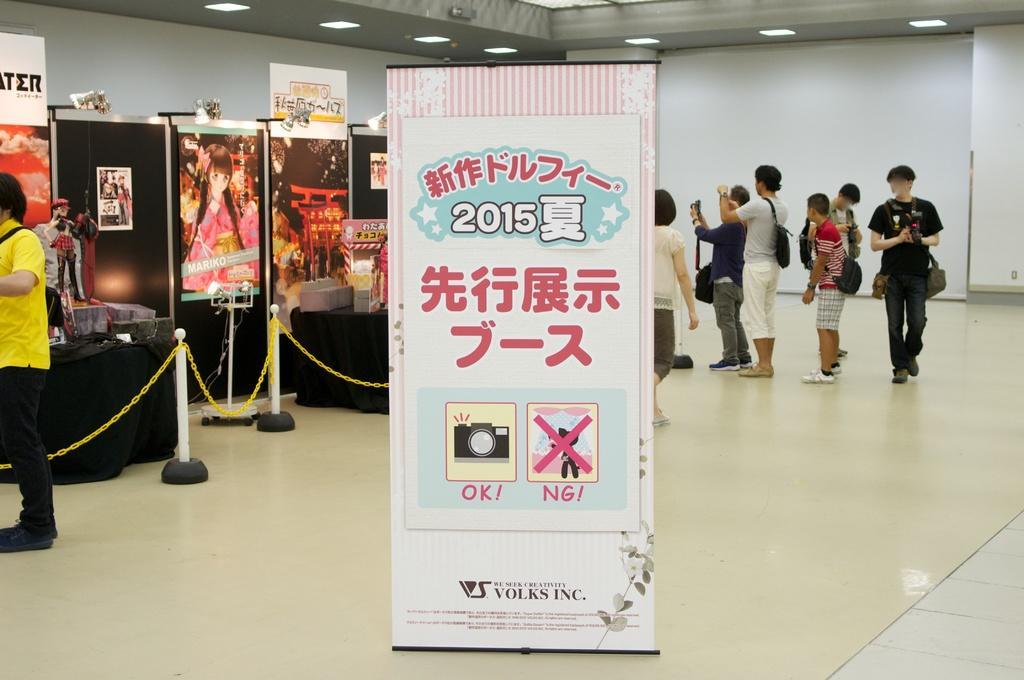How would you summarize this image in a sentence or two? In the image we can see there are many people standing and some of them are walking, they are wearing clothes, shoes and some of them are carrying bags. Here we can see the banners and text on it. Here we can see police, lights and the floor. 